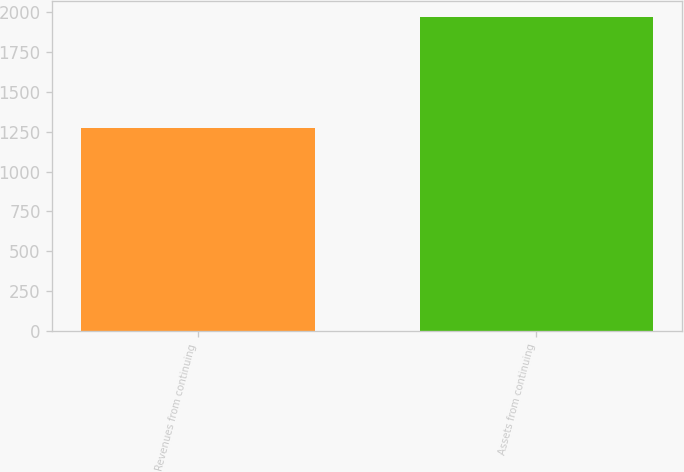<chart> <loc_0><loc_0><loc_500><loc_500><bar_chart><fcel>Revenues from continuing<fcel>Assets from continuing<nl><fcel>1269.8<fcel>1969.7<nl></chart> 